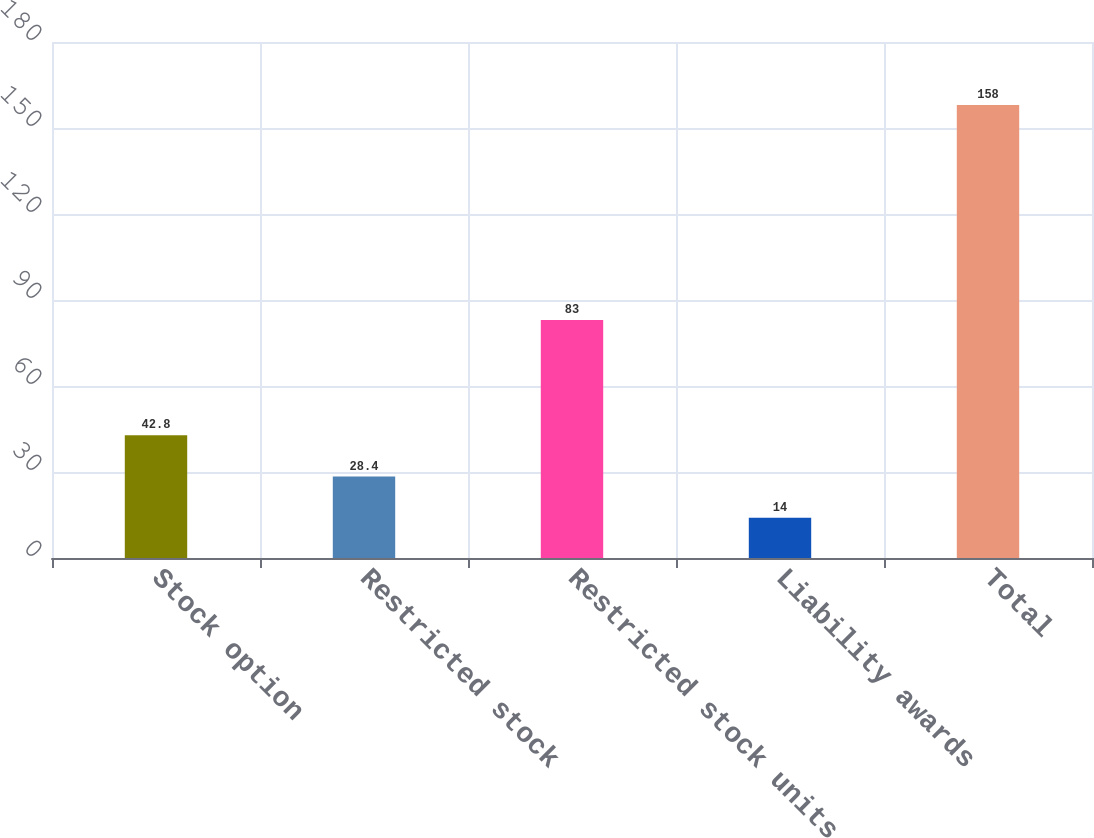Convert chart to OTSL. <chart><loc_0><loc_0><loc_500><loc_500><bar_chart><fcel>Stock option<fcel>Restricted stock<fcel>Restricted stock units<fcel>Liability awards<fcel>Total<nl><fcel>42.8<fcel>28.4<fcel>83<fcel>14<fcel>158<nl></chart> 